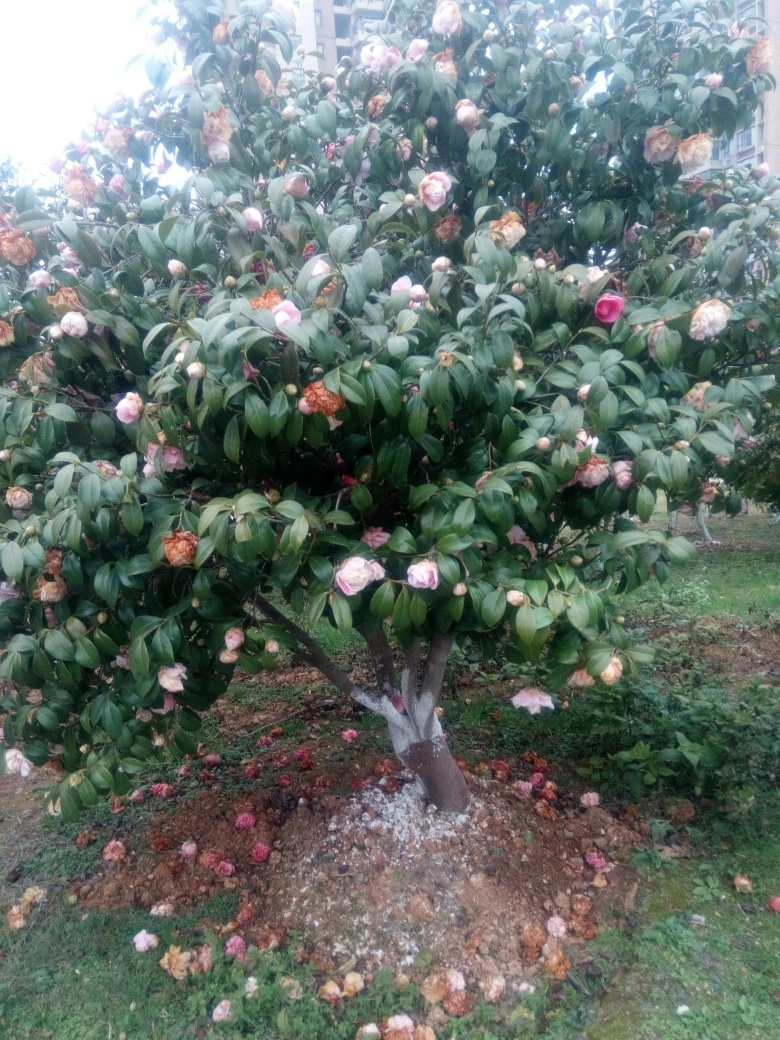What is the overall sharpness like in this image?
A. Soft
B. Excellent
C. Unfocused
Answer with the option's letter from the given choices directly.
 B. 